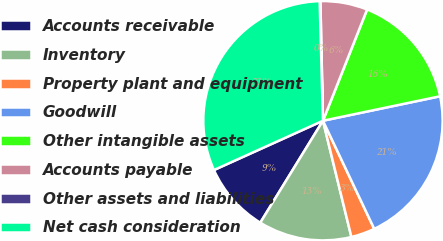Convert chart. <chart><loc_0><loc_0><loc_500><loc_500><pie_chart><fcel>Accounts receivable<fcel>Inventory<fcel>Property plant and equipment<fcel>Goodwill<fcel>Other intangible assets<fcel>Accounts payable<fcel>Other assets and liabilities<fcel>Net cash consideration<nl><fcel>9.47%<fcel>12.59%<fcel>3.23%<fcel>21.23%<fcel>15.71%<fcel>6.35%<fcel>0.1%<fcel>31.32%<nl></chart> 